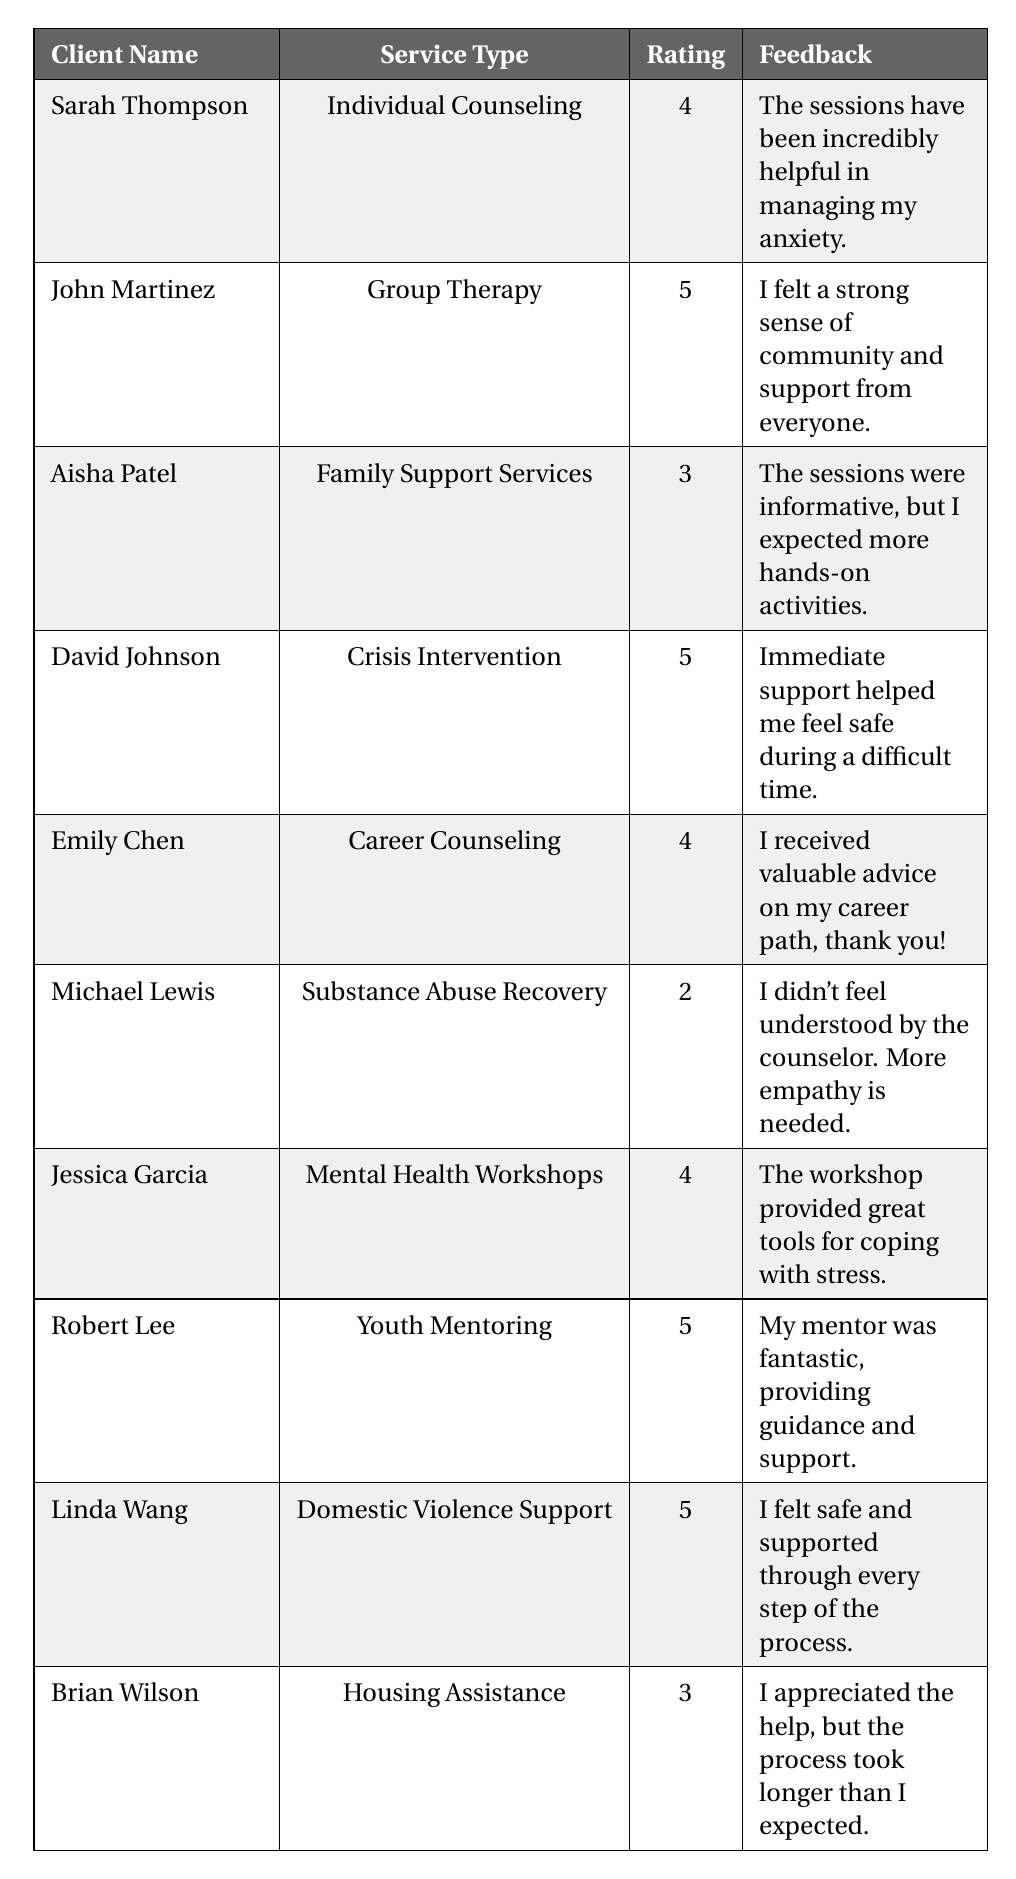What rating did Aisha Patel give for Family Support Services? Aisha Patel's feedback entry specifically lists her rating as 3 for Family Support Services.
Answer: 3 What feedback did Jessica Garcia provide regarding Mental Health Workshops? Jessica Garcia's feedback states that the workshop provided great tools for coping with stress.
Answer: The workshop provided great tools for coping with stress How many clients rated their service with a 5? The clients who rated their service with a 5 are John Martinez, David Johnson, Robert Lee, and Linda Wang, totaling 4 clients.
Answer: 4 What is the average rating of all services provided? The ratings are 4, 5, 3, 5, 4, 2, 4, 5, 5, and 3. The sum of these ratings is 46, and there are 10 clients, thus the average is 46 / 10 = 4.6.
Answer: 4.6 Did Michael Lewis offer positive feedback on Substance Abuse Recovery? Michael Lewis provided feedback indicating he did not feel understood by the counselor, suggesting negative feedback on the service.
Answer: No Which service type received the highest rating and what was it? Looking at the ratings, the highest rating of 5 was given for Crisis Intervention, Group Therapy, Youth Mentoring, and Domestic Violence Support.
Answer: 5 How many clients mentioned that they appreciated the support but had some complaints or suggestions? Aisha Patel, Michael Lewis, and Brian Wilson mentioned they appreciated the help but also expressed some dissatisfaction or suggestions, totaling 3 clients.
Answer: 3 What is the difference between the highest and lowest ratings given? The highest rating is 5, provided by four clients, and the lowest rating is 2, given by Michael Lewis. The difference is 5 - 2 = 3.
Answer: 3 